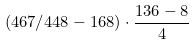Convert formula to latex. <formula><loc_0><loc_0><loc_500><loc_500>( 4 6 7 / 4 4 8 - 1 6 8 ) \cdot \frac { 1 3 6 - 8 } { 4 }</formula> 